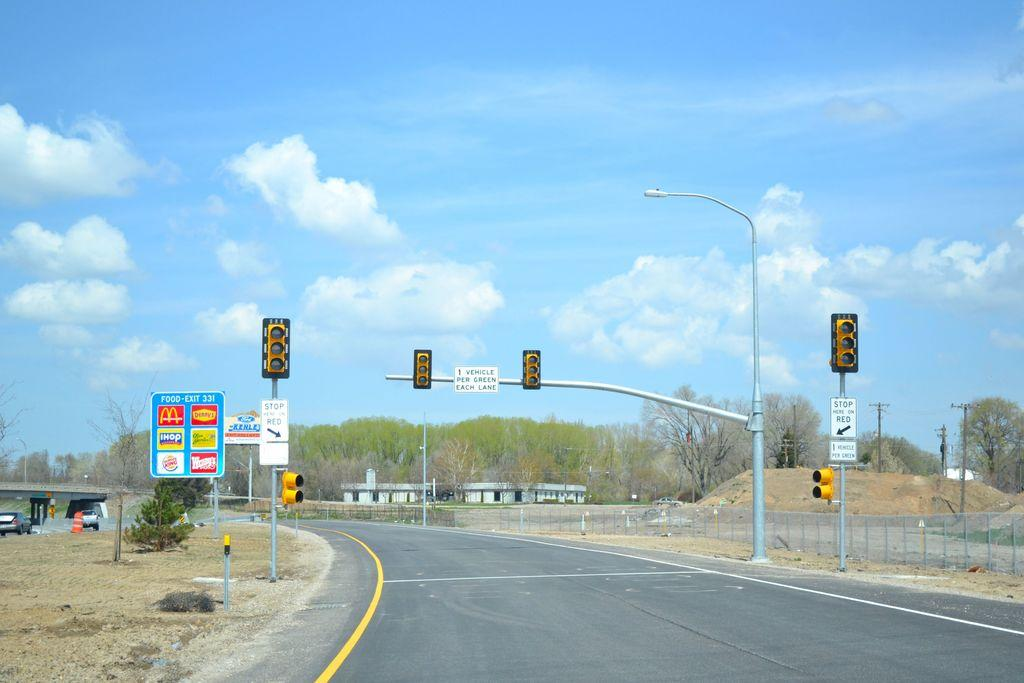<image>
Describe the image concisely. An on ramp to a freeway only allows one vehicle per green light for each lane. 